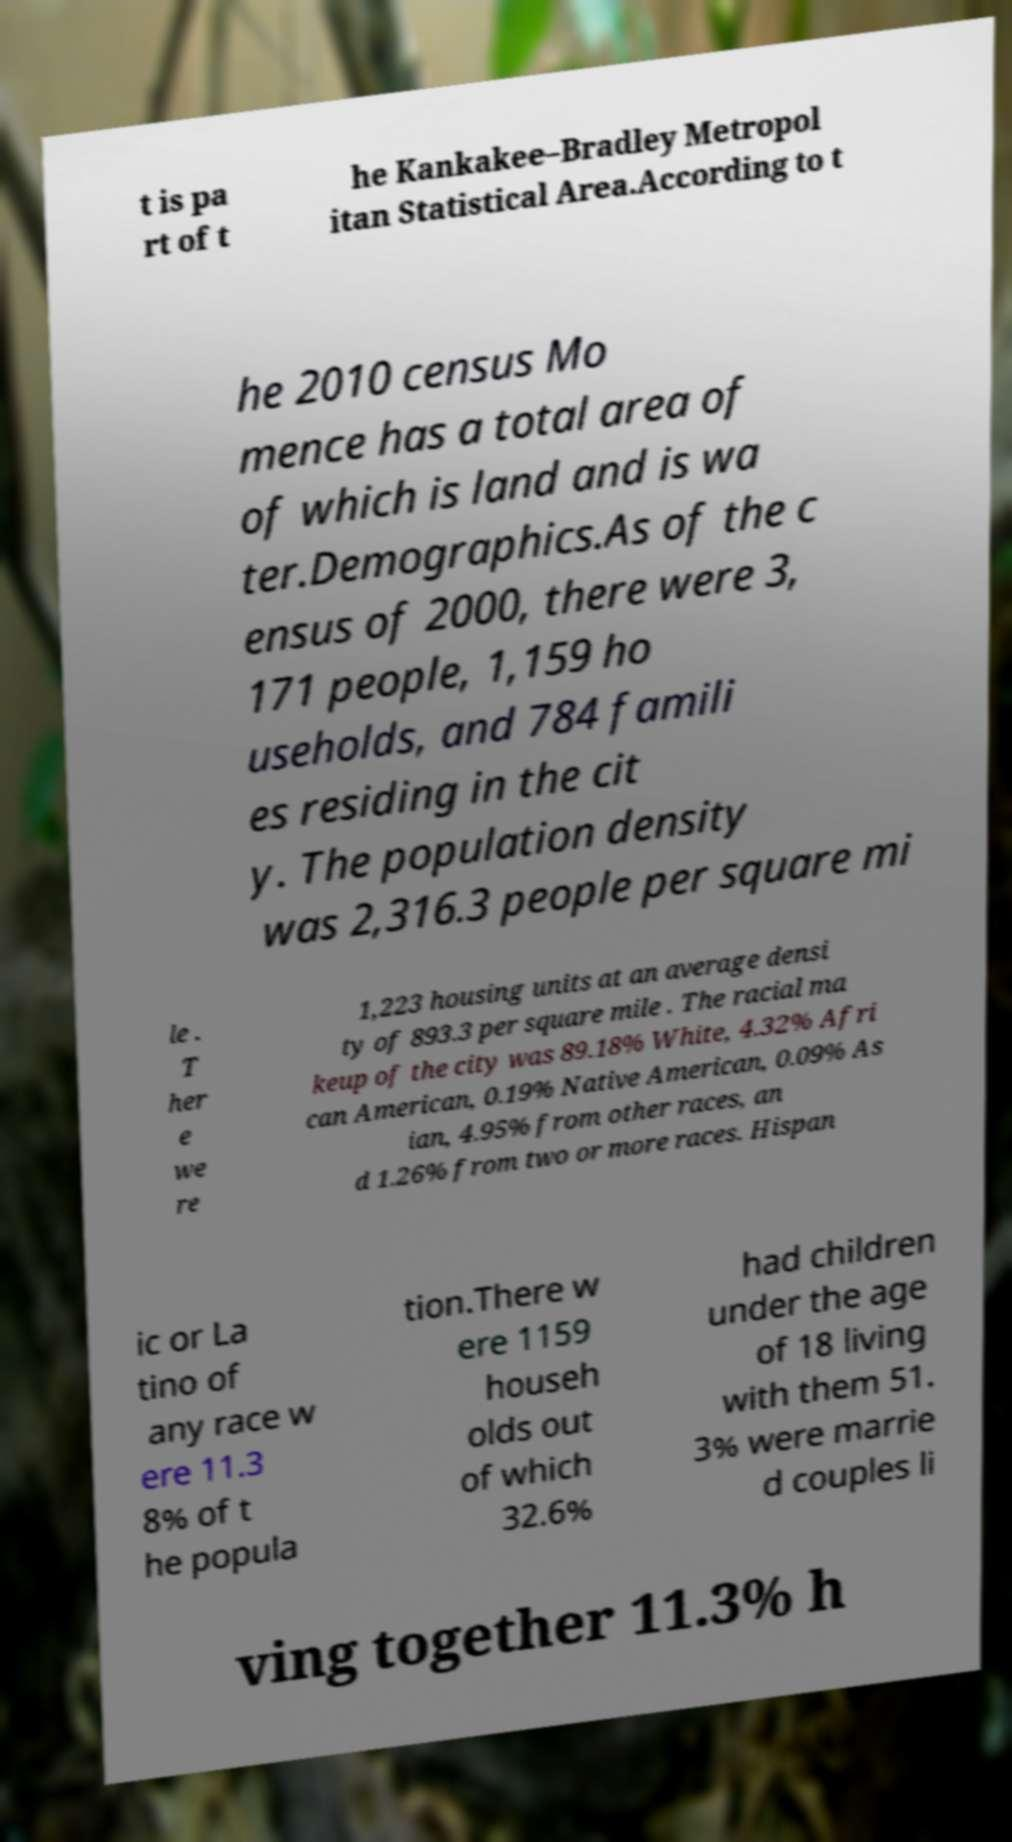Can you read and provide the text displayed in the image?This photo seems to have some interesting text. Can you extract and type it out for me? t is pa rt of t he Kankakee–Bradley Metropol itan Statistical Area.According to t he 2010 census Mo mence has a total area of of which is land and is wa ter.Demographics.As of the c ensus of 2000, there were 3, 171 people, 1,159 ho useholds, and 784 famili es residing in the cit y. The population density was 2,316.3 people per square mi le . T her e we re 1,223 housing units at an average densi ty of 893.3 per square mile . The racial ma keup of the city was 89.18% White, 4.32% Afri can American, 0.19% Native American, 0.09% As ian, 4.95% from other races, an d 1.26% from two or more races. Hispan ic or La tino of any race w ere 11.3 8% of t he popula tion.There w ere 1159 househ olds out of which 32.6% had children under the age of 18 living with them 51. 3% were marrie d couples li ving together 11.3% h 